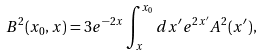<formula> <loc_0><loc_0><loc_500><loc_500>B ^ { 2 } ( x _ { 0 } , x ) = 3 e ^ { - 2 x } \int ^ { x _ { 0 } } _ { x } d x ^ { \prime } e ^ { 2 x ^ { \prime } } A ^ { 2 } ( x ^ { \prime } ) ,</formula> 